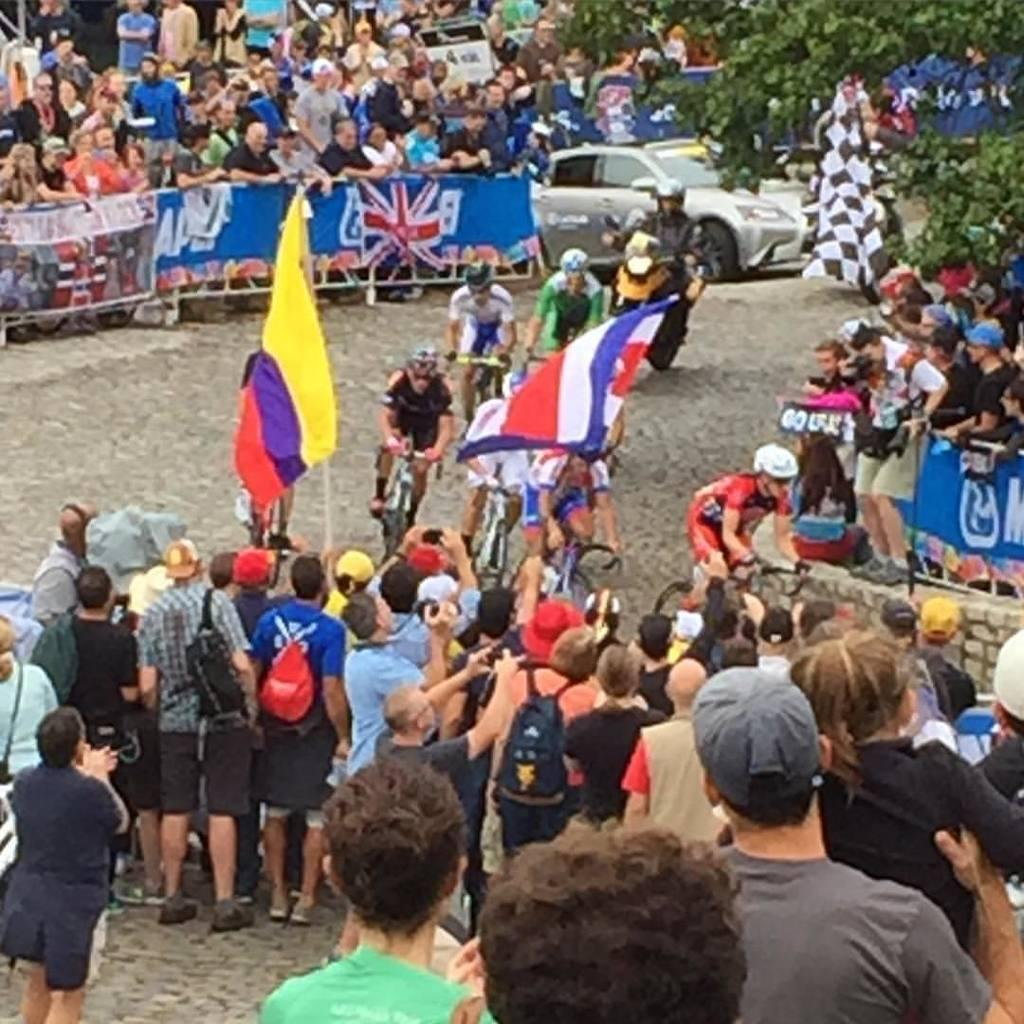How many people are in the image? There is a group of people in the image, but the exact number is not specified. What are some of the people doing in the image? Some people are riding bicycles in the image. What else can be seen in the image besides the people? There is a vehicle, a fence, flags, and trees in the image. What type of sand can be seen in the image? There is no sand present in the image. What process is being carried out by the people in the image? The provided facts do not specify any particular process being carried out by the people in the image. 